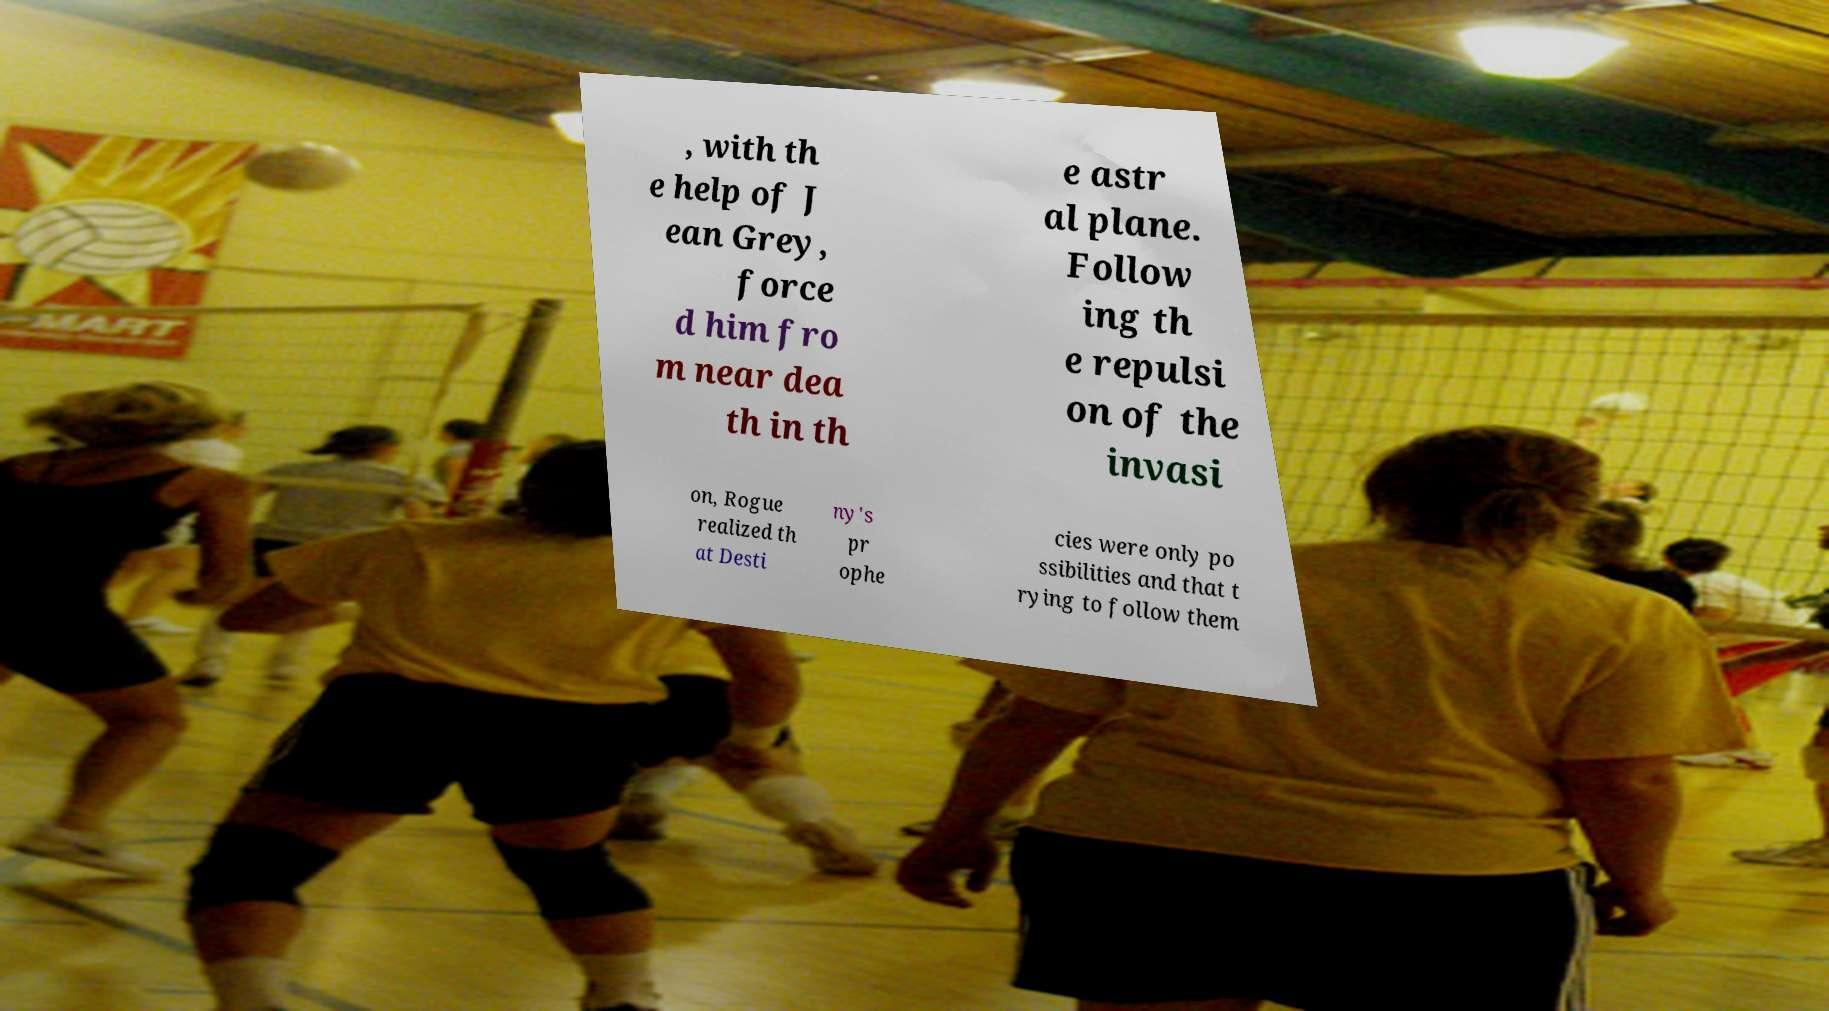Can you read and provide the text displayed in the image?This photo seems to have some interesting text. Can you extract and type it out for me? , with th e help of J ean Grey, force d him fro m near dea th in th e astr al plane. Follow ing th e repulsi on of the invasi on, Rogue realized th at Desti ny's pr ophe cies were only po ssibilities and that t rying to follow them 